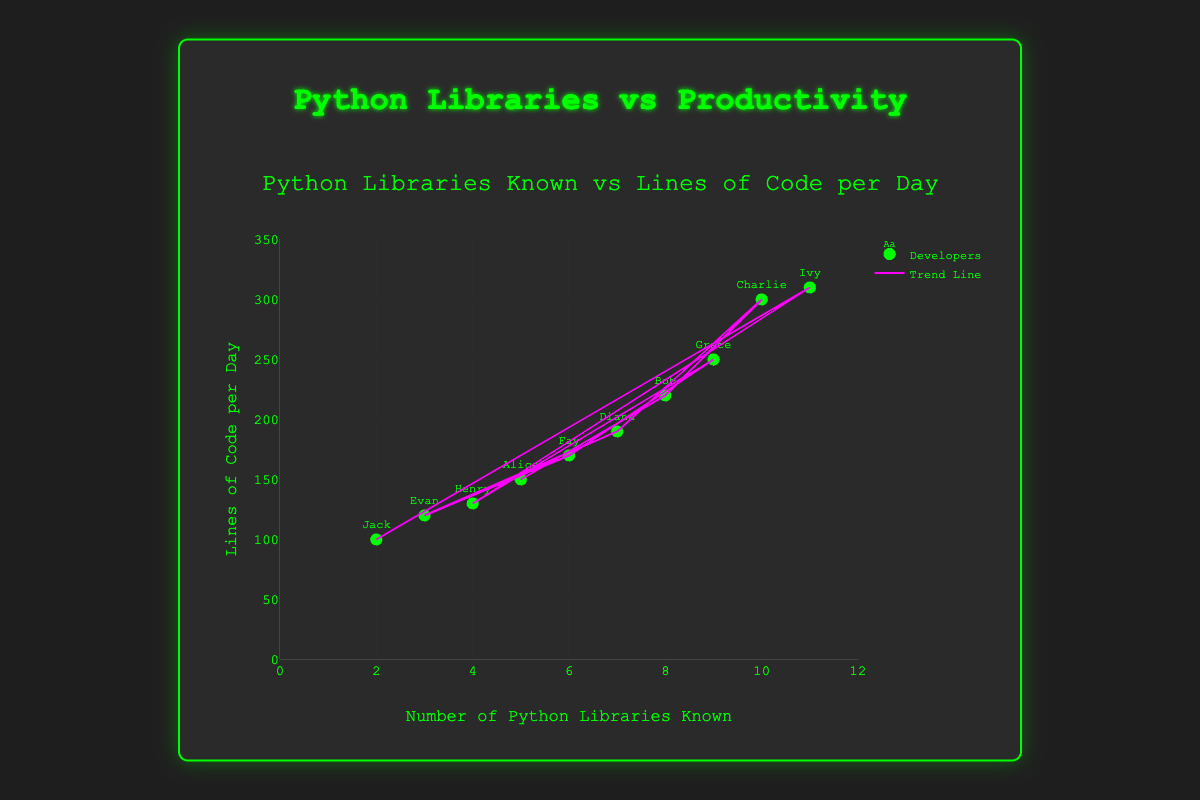What is the overall trend in the relationship between the number of Python libraries known and productivity? The plot shows a scatter of data points where each point represents a developer. There is also a trend line that goes upward, indicating a positive correlation between the number of Python libraries known and lines of code written per day.
Answer: Positive correlation What is the title of the plot? The title is prominently displayed at the top of the plot.
Answer: Python Libraries Known vs Lines of Code per Day How many developers know exactly 7 Python libraries and what is their productivity? The data point for Diana shows she knows 7 Python libraries and has a productivity of 190 lines of code per day. This information is gathered by analyzing the scatter plot points.
Answer: 1 developer, 190 lines of code per day Who has the highest productivity, and how many Python libraries do they know? According to the plot, Ivy has the highest productivity with 310 lines of code per day and she knows 11 Python libraries. This is identified by looking at the highest point on the y-axis.
Answer: Ivy, 11 libraries What is the range of the x-axis? The x-axis represents the number of Python libraries known and ranges from 0 to 12, as indicated by the axis labels and ticks.
Answer: 0 to 12 Which developer knows the least number of Python libraries and what is their productivity? Jack appears to know the least number of Python libraries, which is 2, and his productivity is 100 lines of code per day. This is determined by finding the lowest x-axis value.
Answer: Jack, 100 lines of code per day What is the average productivity of developers who know more than 5 Python libraries? The developers who know more than 5 libraries are Bob (220), Charlie (300), Diana (190), Grace (250), Ivy (310). Sum these values (220 + 300 + 190 + 250 + 310) = 1270. There are 5 developers, so the average is 1270/5 = 254.
Answer: 254 lines of code per day What is the difference in productivity between developers who know 4 libraries and those who know 10 libraries? Henry knows 4 libraries with 130 lines of code per day, and Charlie knows 10 libraries with 300 lines of code per day. The difference is 300 - 130 = 170.
Answer: 170 lines of code per day Which data point is an outlier, if any, and why? An outlier would be significantly away from the trend line. Jack, who knows 2 libraries and writes 100 lines of code per day, is lower than expected productivity based on the trend line.
Answer: Jack How can you describe the relationship between the number of libraries known and lines of code per day shown by the trend line? The trend line shows that as the number of Python libraries known increases, the lines of code per day also tend to increase, indicating a positive correlation. This is demonstrated by the upward slope of the trend line on the scatter plot.
Answer: Positive correlation 